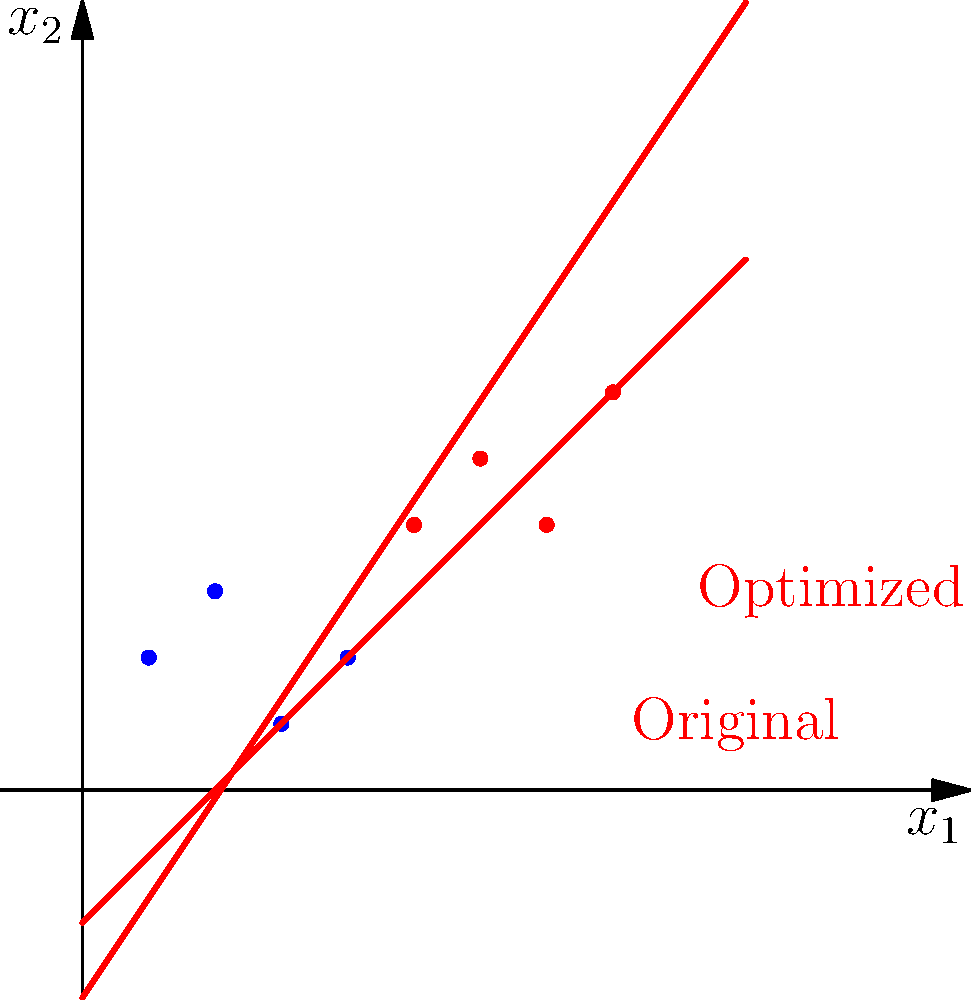Given the visualization of a support vector machine (SVM) classifier with two decision boundaries, one original and one optimized, which hyperparameter is most likely to have been adjusted to achieve this improvement in the decision boundary?

A) Kernel function
B) Regularization parameter (C)
C) Gamma parameter
D) Degree of polynomial kernel To answer this question, let's analyze the changes in the decision boundary and relate them to SVM hyperparameters:

1. The decision boundary has slightly rotated and shifted, indicating a change in the model's fit to the data.

2. The kernel function (option A) determines the shape of the decision boundary. Since both boundaries are still linear, it's unlikely that the kernel function was changed.

3. The regularization parameter C (option B) controls the trade-off between achieving a wide margin and minimizing the classification error. Adjusting C can cause the decision boundary to shift to better separate the classes while potentially allowing for some misclassifications.

4. The gamma parameter (option C) is specific to certain kernel functions like RBF and is not applicable to linear SVMs, which appears to be the case here.

5. The degree of the polynomial kernel (option D) is irrelevant for linear SVMs and would result in a non-linear decision boundary if changed.

Given these observations, the most likely parameter to have been adjusted is the regularization parameter C. This adjustment would allow the model to find a better balance between maximizing the margin and minimizing classification errors, resulting in the observed shift and rotation of the decision boundary.
Answer: B) Regularization parameter (C) 